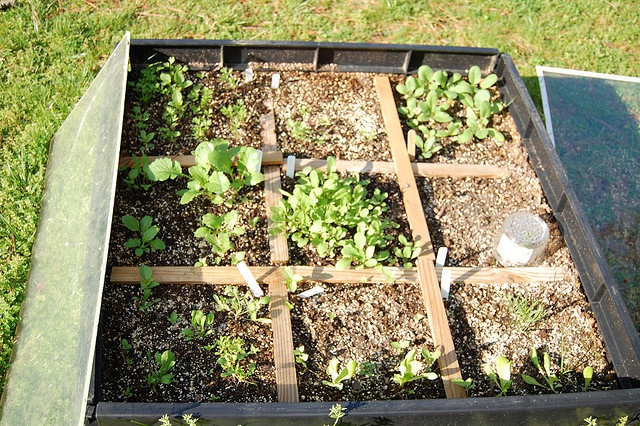Describe the objects in this image and their specific colors. I can see various objects in this image with different colors. 